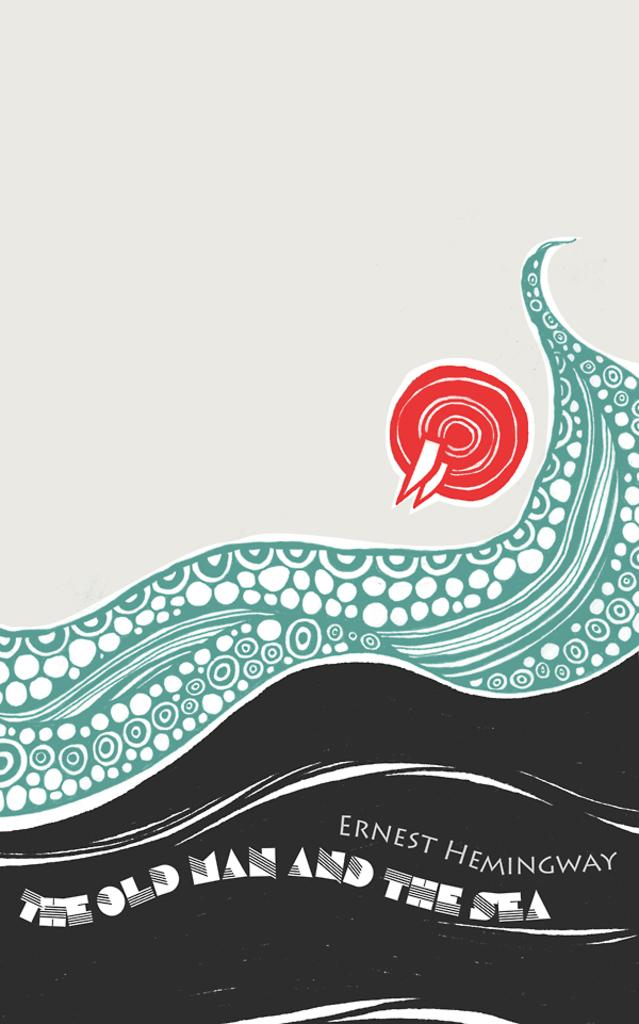Provide a one-sentence caption for the provided image. The cover of an Earnest Hemingway book has a blue wave on it. 